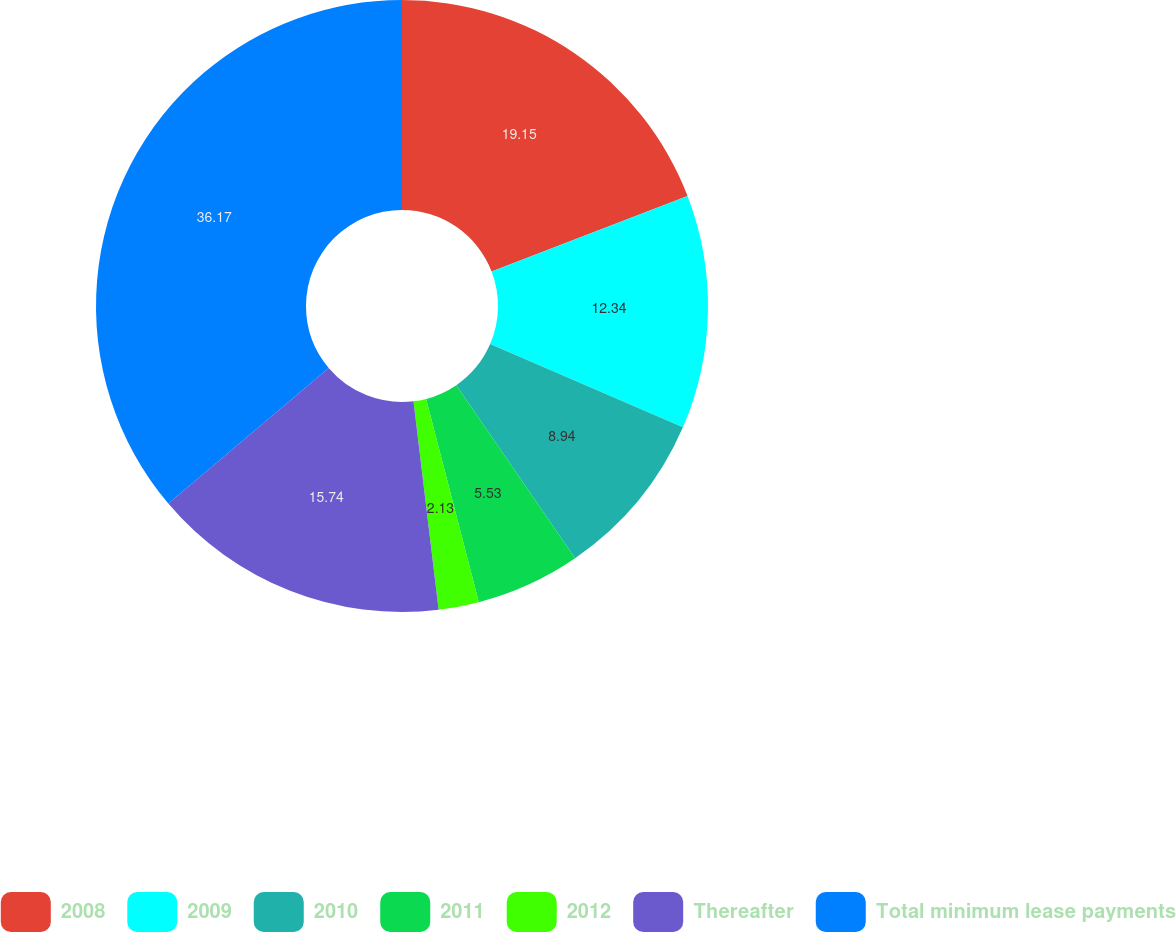Convert chart to OTSL. <chart><loc_0><loc_0><loc_500><loc_500><pie_chart><fcel>2008<fcel>2009<fcel>2010<fcel>2011<fcel>2012<fcel>Thereafter<fcel>Total minimum lease payments<nl><fcel>19.15%<fcel>12.34%<fcel>8.94%<fcel>5.53%<fcel>2.13%<fcel>15.74%<fcel>36.17%<nl></chart> 